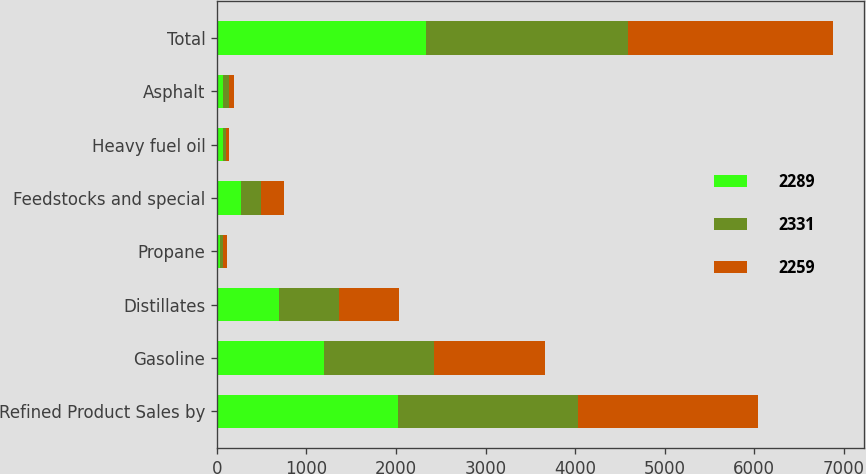Convert chart to OTSL. <chart><loc_0><loc_0><loc_500><loc_500><stacked_bar_chart><ecel><fcel>Refined Product Sales by<fcel>Gasoline<fcel>Distillates<fcel>Propane<fcel>Feedstocks and special<fcel>Heavy fuel oil<fcel>Asphalt<fcel>Total<nl><fcel>2289<fcel>2017<fcel>1201<fcel>691<fcel>37<fcel>265<fcel>69<fcel>68<fcel>2331<nl><fcel>2331<fcel>2016<fcel>1219<fcel>676<fcel>35<fcel>231<fcel>35<fcel>63<fcel>2259<nl><fcel>2259<fcel>2015<fcel>1241<fcel>667<fcel>36<fcel>258<fcel>30<fcel>57<fcel>2289<nl></chart> 